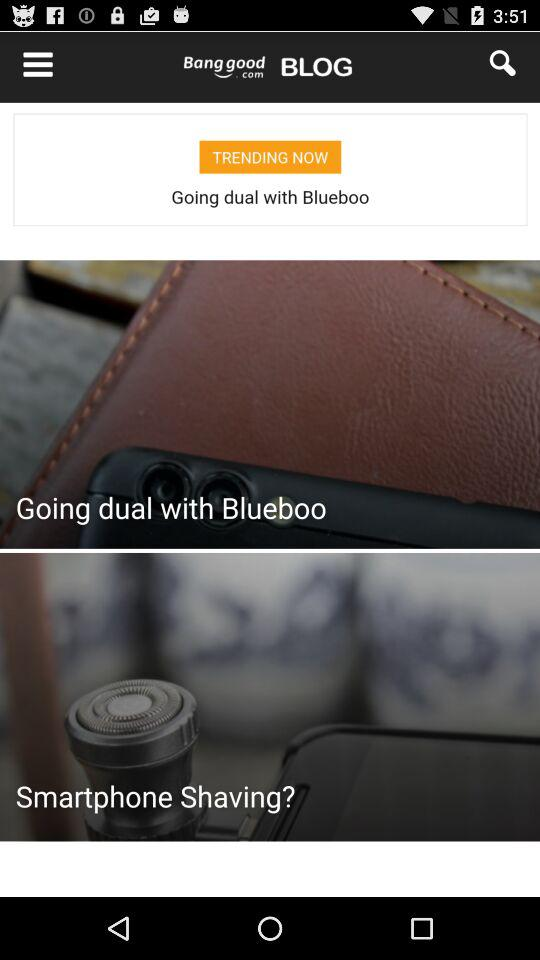What is the discounted price? The discounted price is US$21.99. 